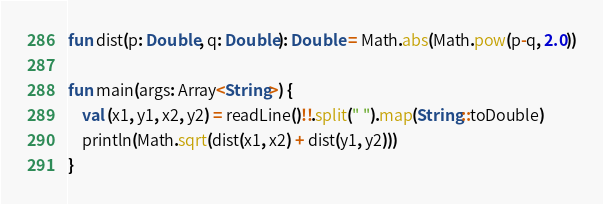<code> <loc_0><loc_0><loc_500><loc_500><_Kotlin_>fun dist(p: Double, q: Double): Double = Math.abs(Math.pow(p-q, 2.0))

fun main(args: Array<String>) {
    val (x1, y1, x2, y2) = readLine()!!.split(" ").map(String::toDouble)
    println(Math.sqrt(dist(x1, x2) + dist(y1, y2)))
}
</code> 